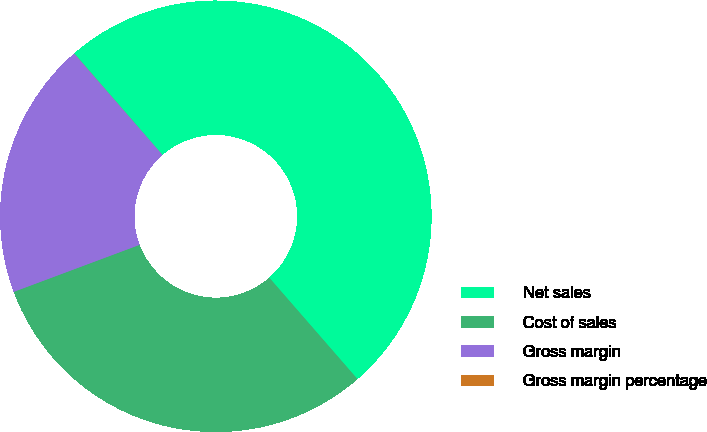<chart> <loc_0><loc_0><loc_500><loc_500><pie_chart><fcel>Net sales<fcel>Cost of sales<fcel>Gross margin<fcel>Gross margin percentage<nl><fcel>49.99%<fcel>30.7%<fcel>19.29%<fcel>0.01%<nl></chart> 